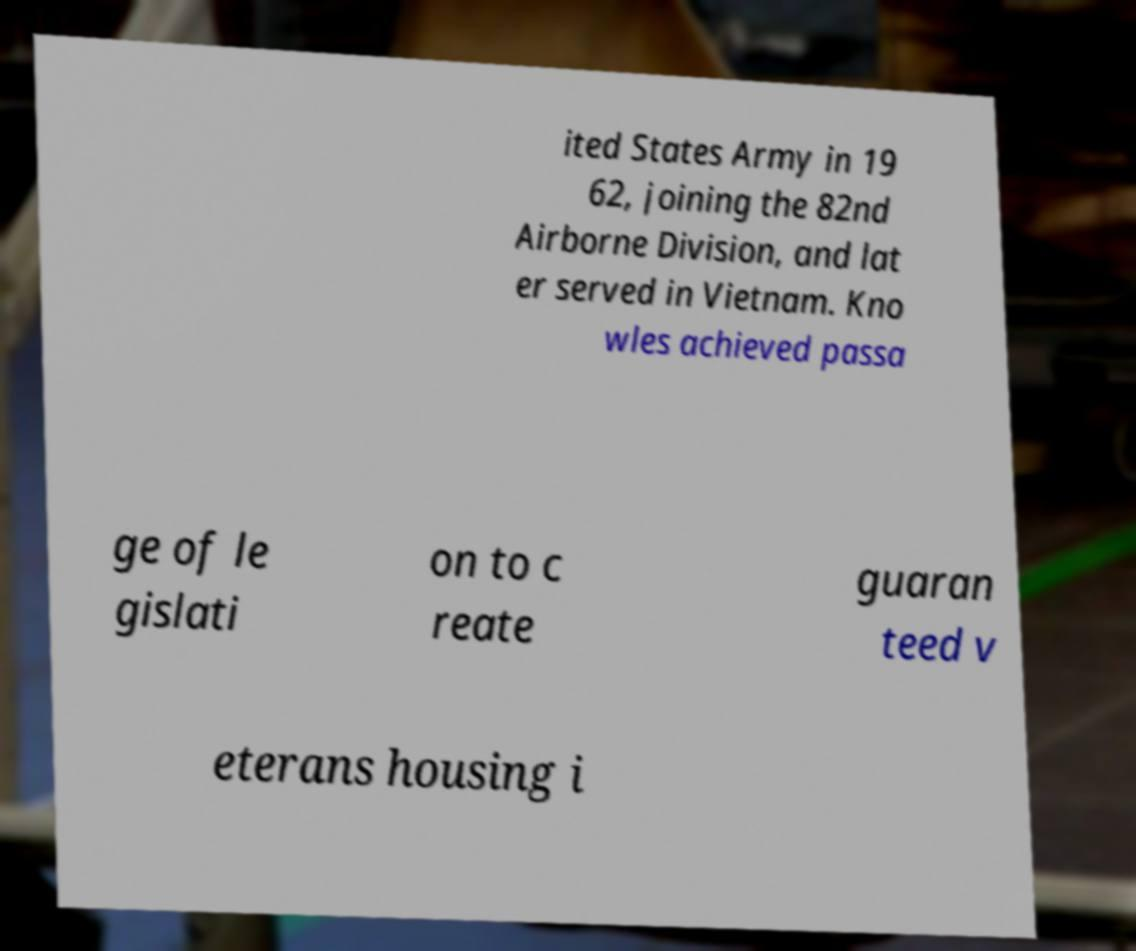What messages or text are displayed in this image? I need them in a readable, typed format. ited States Army in 19 62, joining the 82nd Airborne Division, and lat er served in Vietnam. Kno wles achieved passa ge of le gislati on to c reate guaran teed v eterans housing i 